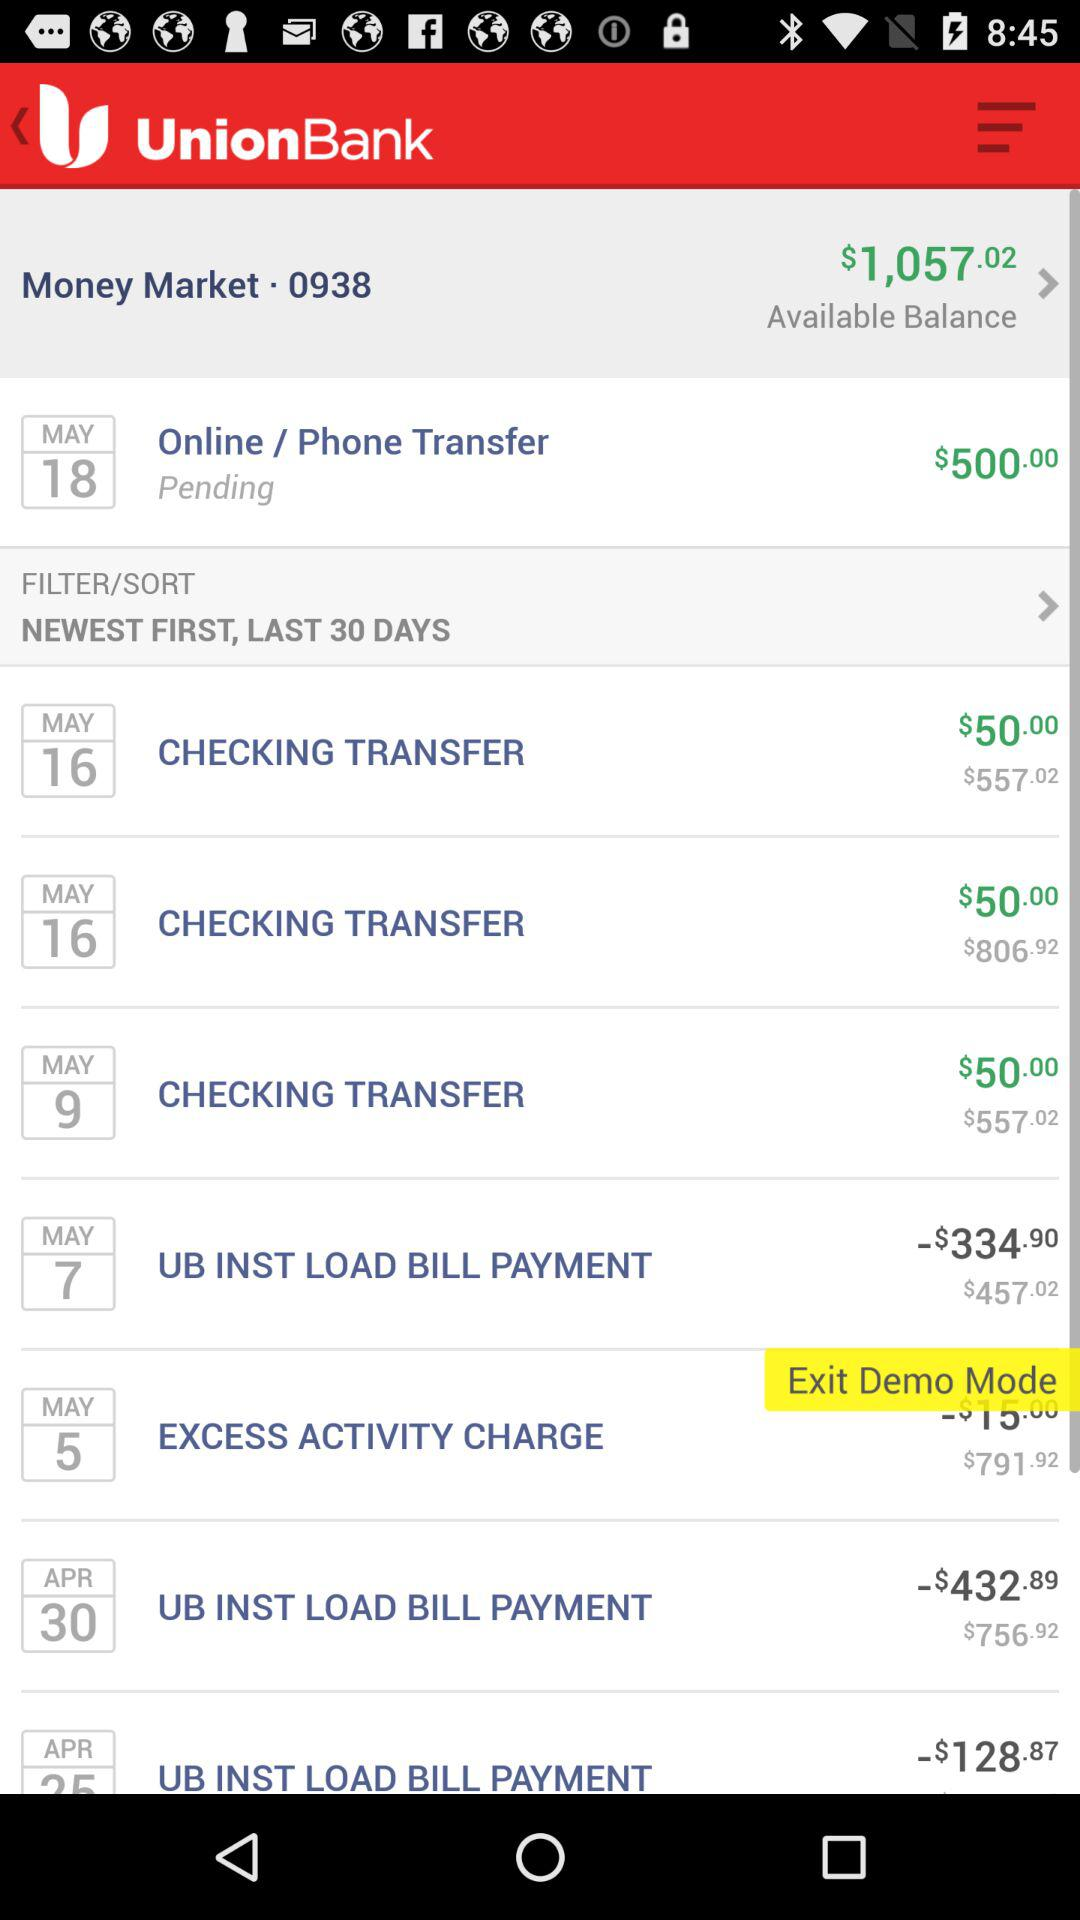What is the currency for the transactions? The currency is $. 